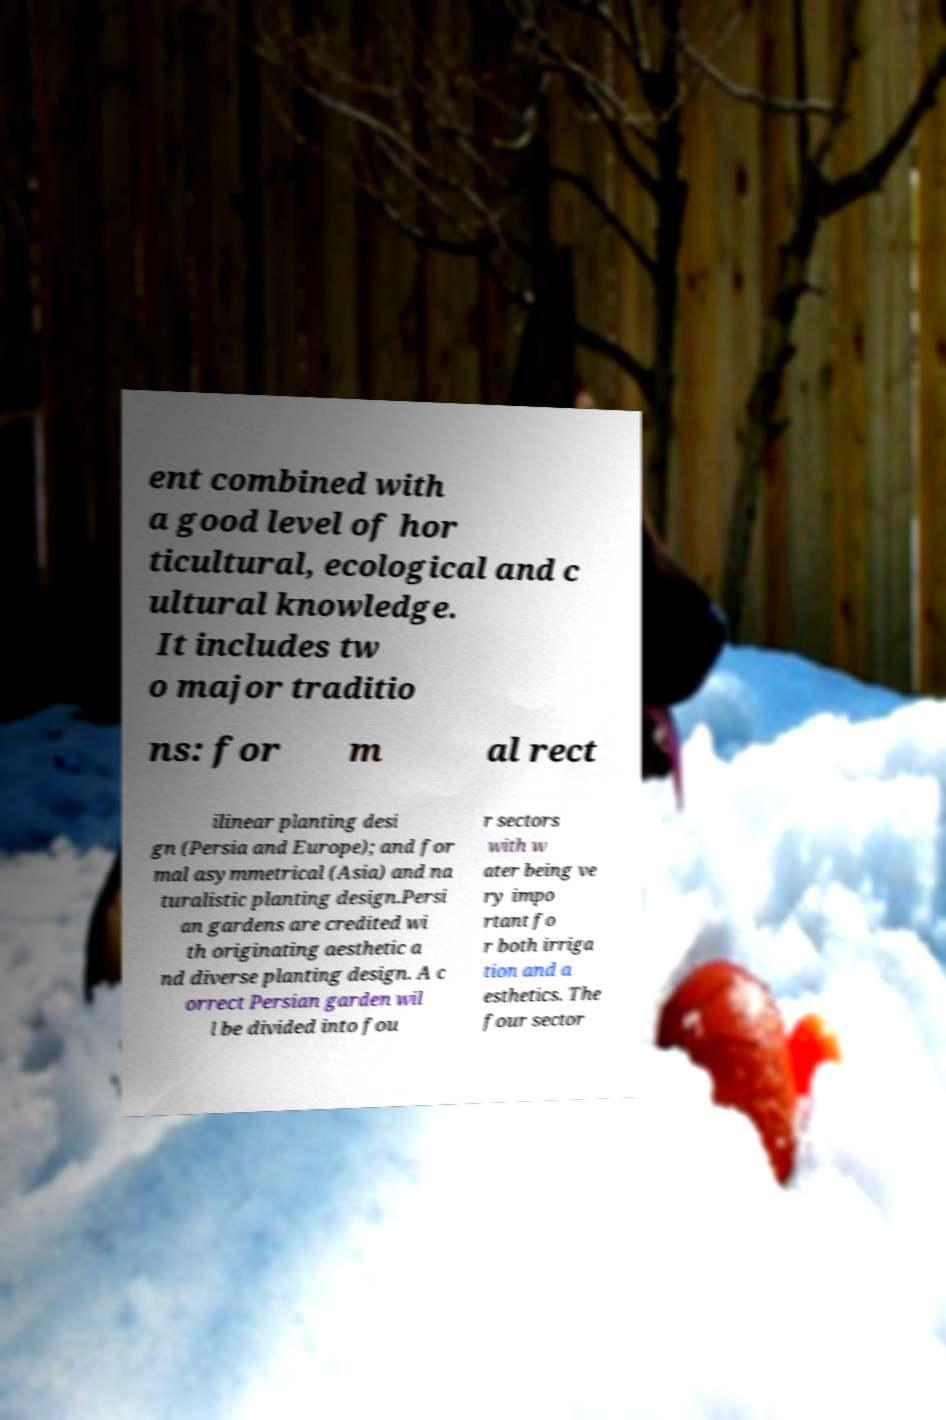What messages or text are displayed in this image? I need them in a readable, typed format. ent combined with a good level of hor ticultural, ecological and c ultural knowledge. It includes tw o major traditio ns: for m al rect ilinear planting desi gn (Persia and Europe); and for mal asymmetrical (Asia) and na turalistic planting design.Persi an gardens are credited wi th originating aesthetic a nd diverse planting design. A c orrect Persian garden wil l be divided into fou r sectors with w ater being ve ry impo rtant fo r both irriga tion and a esthetics. The four sector 